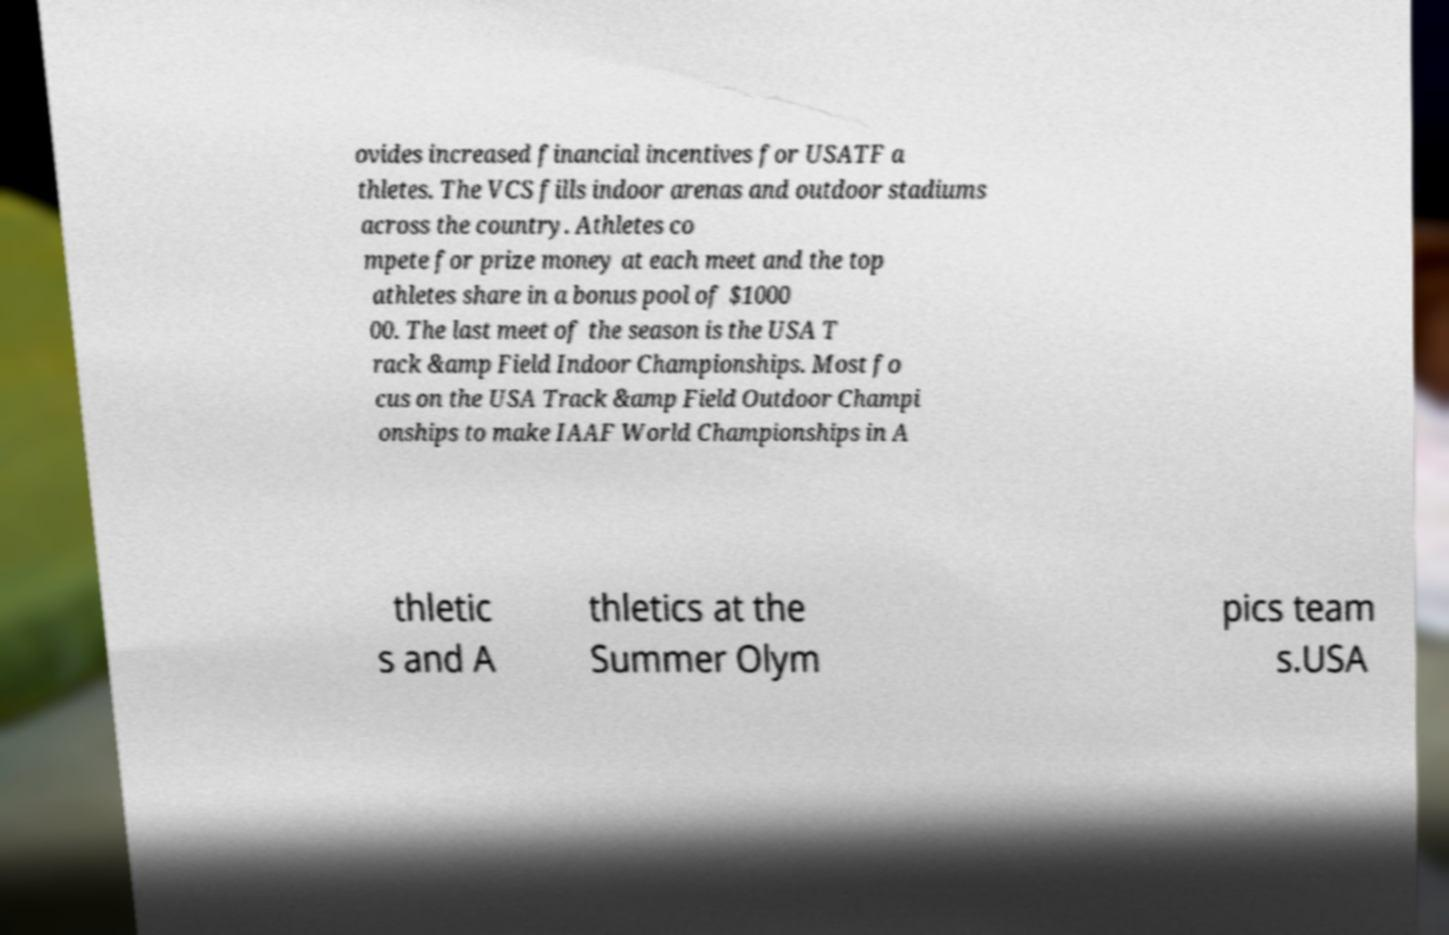Can you read and provide the text displayed in the image?This photo seems to have some interesting text. Can you extract and type it out for me? ovides increased financial incentives for USATF a thletes. The VCS fills indoor arenas and outdoor stadiums across the country. Athletes co mpete for prize money at each meet and the top athletes share in a bonus pool of $1000 00. The last meet of the season is the USA T rack &amp Field Indoor Championships. Most fo cus on the USA Track &amp Field Outdoor Champi onships to make IAAF World Championships in A thletic s and A thletics at the Summer Olym pics team s.USA 